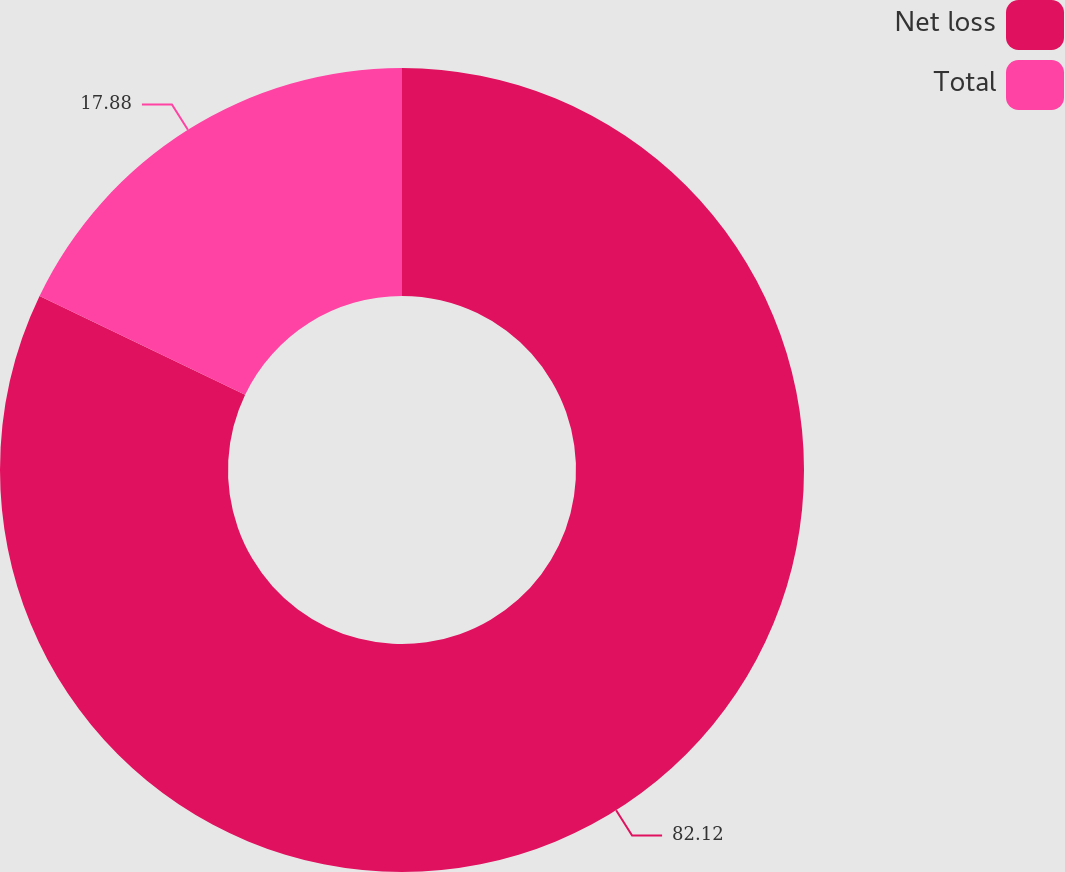Convert chart to OTSL. <chart><loc_0><loc_0><loc_500><loc_500><pie_chart><fcel>Net loss<fcel>Total<nl><fcel>82.12%<fcel>17.88%<nl></chart> 